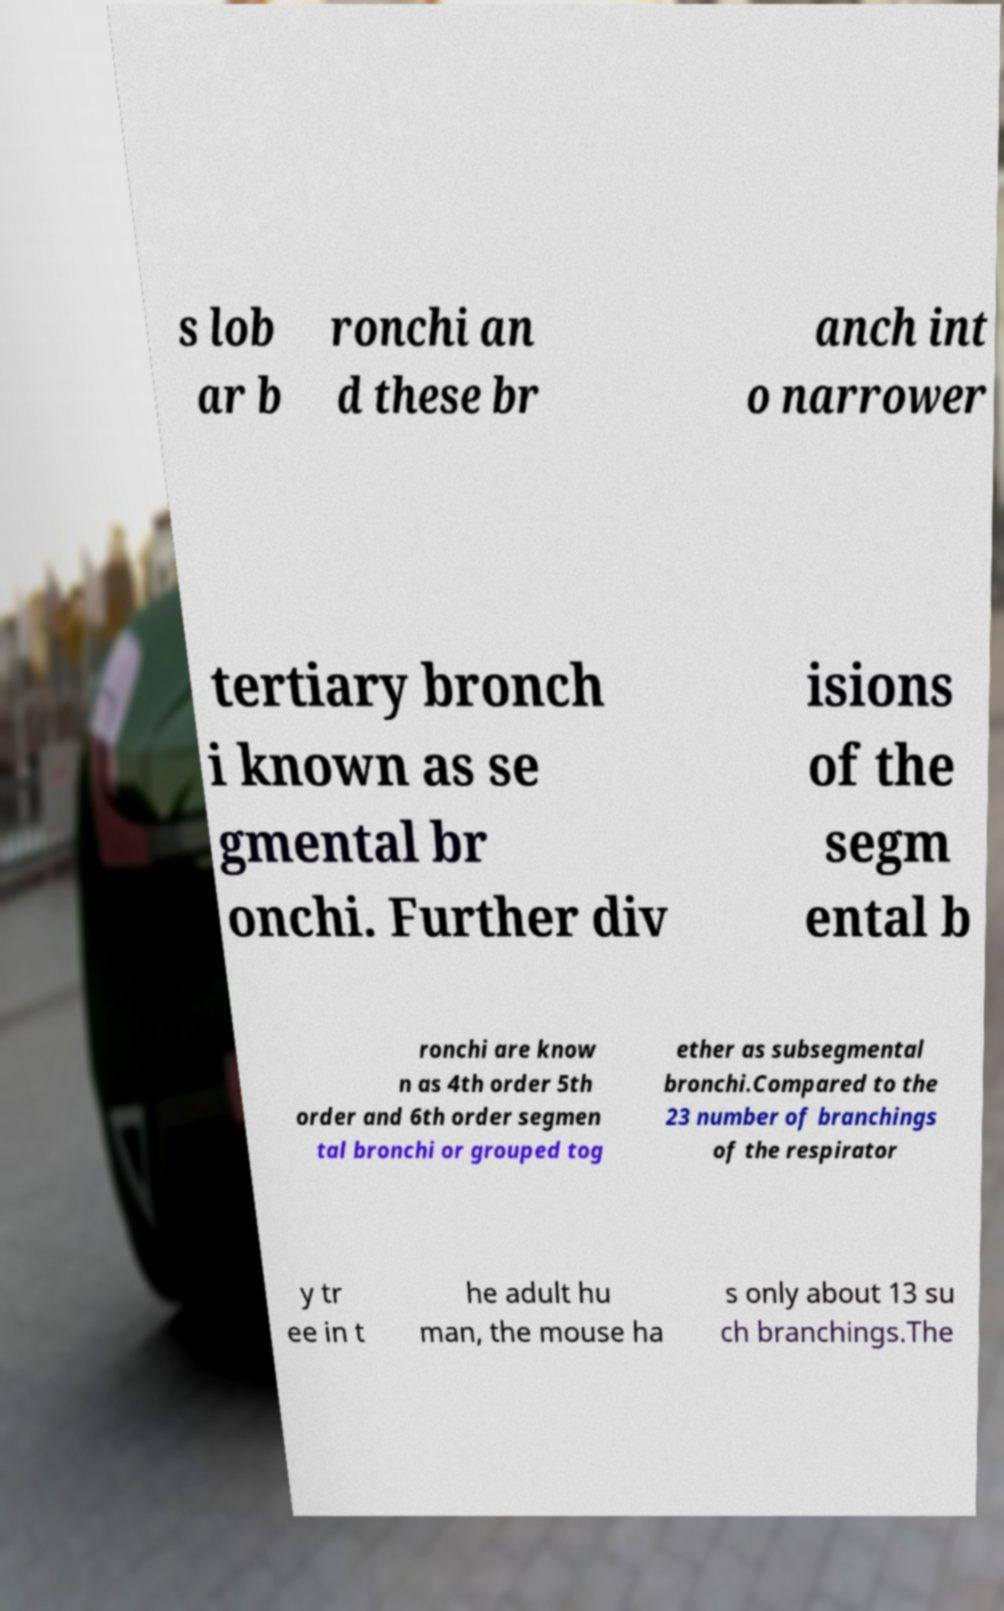Can you read and provide the text displayed in the image?This photo seems to have some interesting text. Can you extract and type it out for me? s lob ar b ronchi an d these br anch int o narrower tertiary bronch i known as se gmental br onchi. Further div isions of the segm ental b ronchi are know n as 4th order 5th order and 6th order segmen tal bronchi or grouped tog ether as subsegmental bronchi.Compared to the 23 number of branchings of the respirator y tr ee in t he adult hu man, the mouse ha s only about 13 su ch branchings.The 